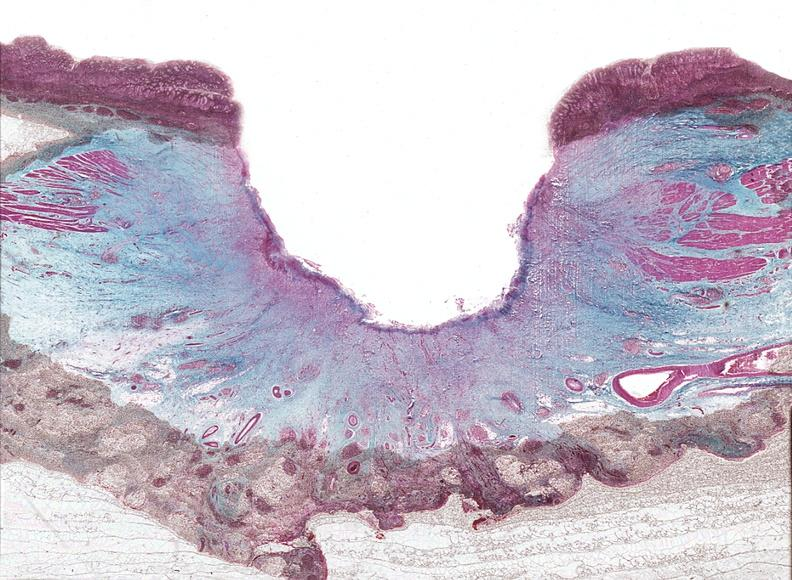s gastrointestinal present?
Answer the question using a single word or phrase. Yes 